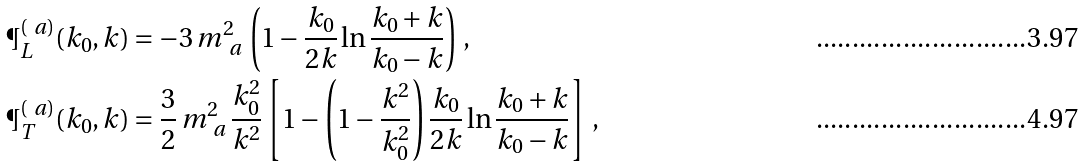<formula> <loc_0><loc_0><loc_500><loc_500>\P _ { L } ^ { ( \ a ) } ( k _ { 0 } , k ) & = - 3 \, m _ { \ a } ^ { 2 } \, \left ( 1 - \frac { k _ { 0 } } { 2 k } \ln { \frac { k _ { 0 } + k } { k _ { 0 } - k } } \right ) \, , \\ \P _ { T } ^ { ( \ a ) } ( k _ { 0 } , k ) & = \frac { 3 } { 2 } \, m _ { \ a } ^ { 2 } \, \frac { k _ { 0 } ^ { 2 } } { k ^ { 2 } } \left [ 1 - \left ( 1 - \frac { k ^ { 2 } } { k _ { 0 } ^ { 2 } } \right ) \frac { k _ { 0 } } { 2 k } \ln { \frac { k _ { 0 } + k } { k _ { 0 } - k } } \right ] \, ,</formula> 